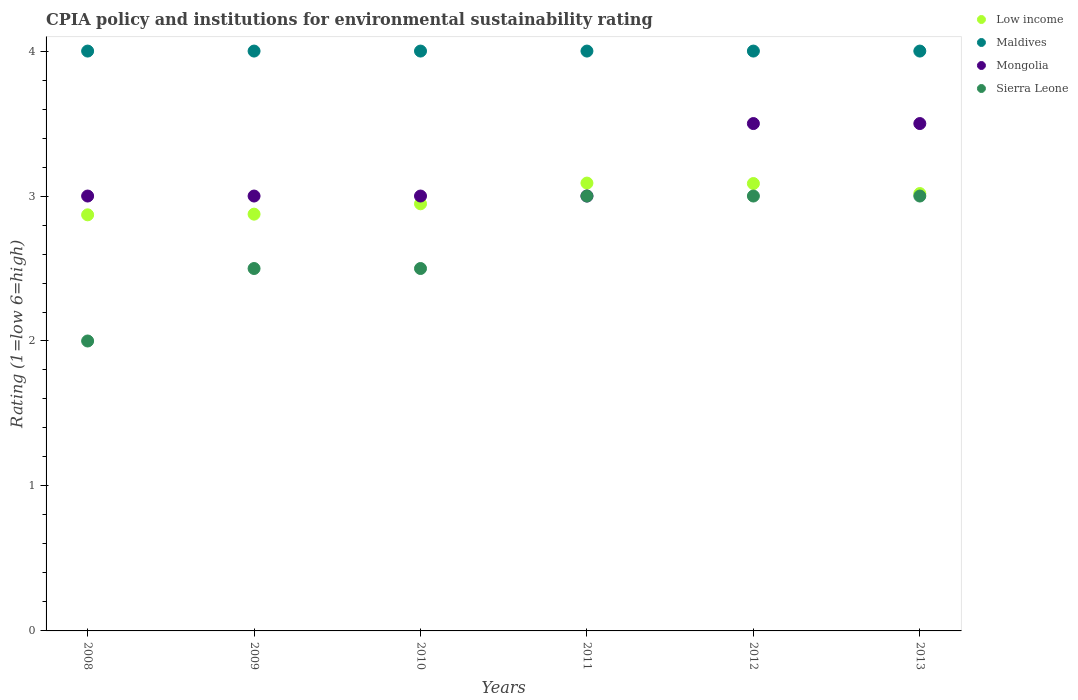How many different coloured dotlines are there?
Make the answer very short. 4. Is the number of dotlines equal to the number of legend labels?
Offer a very short reply. Yes. What is the CPIA rating in Sierra Leone in 2010?
Keep it short and to the point. 2.5. Across all years, what is the minimum CPIA rating in Low income?
Offer a terse response. 2.87. In which year was the CPIA rating in Maldives minimum?
Offer a terse response. 2008. What is the difference between the CPIA rating in Maldives in 2010 and the CPIA rating in Mongolia in 2008?
Offer a very short reply. 1. In the year 2010, what is the difference between the CPIA rating in Mongolia and CPIA rating in Low income?
Offer a very short reply. 0.05. In how many years, is the CPIA rating in Maldives greater than 2.6?
Your response must be concise. 6. What is the ratio of the CPIA rating in Maldives in 2011 to that in 2013?
Provide a succinct answer. 1. Is the CPIA rating in Sierra Leone in 2009 less than that in 2013?
Your answer should be compact. Yes. What is the difference between the highest and the lowest CPIA rating in Mongolia?
Provide a short and direct response. 0.5. In how many years, is the CPIA rating in Mongolia greater than the average CPIA rating in Mongolia taken over all years?
Keep it short and to the point. 2. Does the CPIA rating in Mongolia monotonically increase over the years?
Make the answer very short. No. Is the CPIA rating in Sierra Leone strictly greater than the CPIA rating in Mongolia over the years?
Provide a succinct answer. No. How many years are there in the graph?
Provide a succinct answer. 6. Does the graph contain grids?
Your response must be concise. No. How are the legend labels stacked?
Your answer should be compact. Vertical. What is the title of the graph?
Offer a very short reply. CPIA policy and institutions for environmental sustainability rating. Does "Faeroe Islands" appear as one of the legend labels in the graph?
Your answer should be compact. No. What is the Rating (1=low 6=high) of Low income in 2008?
Your answer should be compact. 2.87. What is the Rating (1=low 6=high) of Maldives in 2008?
Keep it short and to the point. 4. What is the Rating (1=low 6=high) in Low income in 2009?
Give a very brief answer. 2.88. What is the Rating (1=low 6=high) of Maldives in 2009?
Offer a terse response. 4. What is the Rating (1=low 6=high) in Mongolia in 2009?
Ensure brevity in your answer.  3. What is the Rating (1=low 6=high) of Sierra Leone in 2009?
Your answer should be compact. 2.5. What is the Rating (1=low 6=high) in Low income in 2010?
Offer a very short reply. 2.95. What is the Rating (1=low 6=high) in Maldives in 2010?
Your answer should be compact. 4. What is the Rating (1=low 6=high) in Mongolia in 2010?
Provide a short and direct response. 3. What is the Rating (1=low 6=high) of Low income in 2011?
Offer a very short reply. 3.09. What is the Rating (1=low 6=high) of Mongolia in 2011?
Provide a short and direct response. 3. What is the Rating (1=low 6=high) of Low income in 2012?
Provide a short and direct response. 3.09. What is the Rating (1=low 6=high) in Maldives in 2012?
Offer a terse response. 4. What is the Rating (1=low 6=high) of Mongolia in 2012?
Provide a succinct answer. 3.5. What is the Rating (1=low 6=high) of Sierra Leone in 2012?
Offer a very short reply. 3. What is the Rating (1=low 6=high) in Low income in 2013?
Give a very brief answer. 3.02. What is the Rating (1=low 6=high) in Maldives in 2013?
Offer a terse response. 4. What is the Rating (1=low 6=high) in Sierra Leone in 2013?
Keep it short and to the point. 3. Across all years, what is the maximum Rating (1=low 6=high) in Low income?
Keep it short and to the point. 3.09. Across all years, what is the maximum Rating (1=low 6=high) in Mongolia?
Offer a very short reply. 3.5. Across all years, what is the maximum Rating (1=low 6=high) of Sierra Leone?
Make the answer very short. 3. Across all years, what is the minimum Rating (1=low 6=high) of Low income?
Keep it short and to the point. 2.87. Across all years, what is the minimum Rating (1=low 6=high) of Maldives?
Your answer should be very brief. 4. Across all years, what is the minimum Rating (1=low 6=high) in Mongolia?
Ensure brevity in your answer.  3. What is the total Rating (1=low 6=high) of Low income in the graph?
Offer a very short reply. 17.88. What is the total Rating (1=low 6=high) in Sierra Leone in the graph?
Provide a short and direct response. 16. What is the difference between the Rating (1=low 6=high) in Low income in 2008 and that in 2009?
Keep it short and to the point. -0. What is the difference between the Rating (1=low 6=high) in Mongolia in 2008 and that in 2009?
Your response must be concise. 0. What is the difference between the Rating (1=low 6=high) in Sierra Leone in 2008 and that in 2009?
Provide a short and direct response. -0.5. What is the difference between the Rating (1=low 6=high) in Low income in 2008 and that in 2010?
Your answer should be very brief. -0.08. What is the difference between the Rating (1=low 6=high) in Maldives in 2008 and that in 2010?
Your answer should be compact. 0. What is the difference between the Rating (1=low 6=high) in Mongolia in 2008 and that in 2010?
Your answer should be very brief. 0. What is the difference between the Rating (1=low 6=high) of Sierra Leone in 2008 and that in 2010?
Your response must be concise. -0.5. What is the difference between the Rating (1=low 6=high) of Low income in 2008 and that in 2011?
Offer a very short reply. -0.22. What is the difference between the Rating (1=low 6=high) of Mongolia in 2008 and that in 2011?
Ensure brevity in your answer.  0. What is the difference between the Rating (1=low 6=high) of Low income in 2008 and that in 2012?
Keep it short and to the point. -0.22. What is the difference between the Rating (1=low 6=high) in Mongolia in 2008 and that in 2012?
Keep it short and to the point. -0.5. What is the difference between the Rating (1=low 6=high) of Low income in 2008 and that in 2013?
Offer a terse response. -0.15. What is the difference between the Rating (1=low 6=high) in Sierra Leone in 2008 and that in 2013?
Offer a very short reply. -1. What is the difference between the Rating (1=low 6=high) of Low income in 2009 and that in 2010?
Provide a short and direct response. -0.07. What is the difference between the Rating (1=low 6=high) in Sierra Leone in 2009 and that in 2010?
Offer a terse response. 0. What is the difference between the Rating (1=low 6=high) of Low income in 2009 and that in 2011?
Your answer should be compact. -0.21. What is the difference between the Rating (1=low 6=high) of Low income in 2009 and that in 2012?
Provide a succinct answer. -0.21. What is the difference between the Rating (1=low 6=high) of Maldives in 2009 and that in 2012?
Keep it short and to the point. 0. What is the difference between the Rating (1=low 6=high) of Mongolia in 2009 and that in 2012?
Your answer should be compact. -0.5. What is the difference between the Rating (1=low 6=high) in Low income in 2009 and that in 2013?
Your response must be concise. -0.14. What is the difference between the Rating (1=low 6=high) of Mongolia in 2009 and that in 2013?
Give a very brief answer. -0.5. What is the difference between the Rating (1=low 6=high) of Sierra Leone in 2009 and that in 2013?
Keep it short and to the point. -0.5. What is the difference between the Rating (1=low 6=high) of Low income in 2010 and that in 2011?
Your answer should be very brief. -0.14. What is the difference between the Rating (1=low 6=high) in Sierra Leone in 2010 and that in 2011?
Provide a short and direct response. -0.5. What is the difference between the Rating (1=low 6=high) in Low income in 2010 and that in 2012?
Provide a short and direct response. -0.14. What is the difference between the Rating (1=low 6=high) in Maldives in 2010 and that in 2012?
Your answer should be compact. 0. What is the difference between the Rating (1=low 6=high) of Mongolia in 2010 and that in 2012?
Keep it short and to the point. -0.5. What is the difference between the Rating (1=low 6=high) in Sierra Leone in 2010 and that in 2012?
Provide a succinct answer. -0.5. What is the difference between the Rating (1=low 6=high) of Low income in 2010 and that in 2013?
Keep it short and to the point. -0.07. What is the difference between the Rating (1=low 6=high) in Mongolia in 2010 and that in 2013?
Make the answer very short. -0.5. What is the difference between the Rating (1=low 6=high) of Sierra Leone in 2010 and that in 2013?
Ensure brevity in your answer.  -0.5. What is the difference between the Rating (1=low 6=high) in Low income in 2011 and that in 2012?
Your answer should be very brief. 0. What is the difference between the Rating (1=low 6=high) of Maldives in 2011 and that in 2012?
Offer a very short reply. 0. What is the difference between the Rating (1=low 6=high) in Sierra Leone in 2011 and that in 2012?
Make the answer very short. 0. What is the difference between the Rating (1=low 6=high) in Low income in 2011 and that in 2013?
Offer a terse response. 0.07. What is the difference between the Rating (1=low 6=high) of Maldives in 2011 and that in 2013?
Give a very brief answer. 0. What is the difference between the Rating (1=low 6=high) of Sierra Leone in 2011 and that in 2013?
Your answer should be very brief. 0. What is the difference between the Rating (1=low 6=high) in Low income in 2012 and that in 2013?
Your response must be concise. 0.07. What is the difference between the Rating (1=low 6=high) in Mongolia in 2012 and that in 2013?
Offer a very short reply. 0. What is the difference between the Rating (1=low 6=high) in Low income in 2008 and the Rating (1=low 6=high) in Maldives in 2009?
Your answer should be compact. -1.13. What is the difference between the Rating (1=low 6=high) of Low income in 2008 and the Rating (1=low 6=high) of Mongolia in 2009?
Your response must be concise. -0.13. What is the difference between the Rating (1=low 6=high) in Low income in 2008 and the Rating (1=low 6=high) in Sierra Leone in 2009?
Give a very brief answer. 0.37. What is the difference between the Rating (1=low 6=high) in Maldives in 2008 and the Rating (1=low 6=high) in Sierra Leone in 2009?
Your answer should be very brief. 1.5. What is the difference between the Rating (1=low 6=high) of Mongolia in 2008 and the Rating (1=low 6=high) of Sierra Leone in 2009?
Your response must be concise. 0.5. What is the difference between the Rating (1=low 6=high) of Low income in 2008 and the Rating (1=low 6=high) of Maldives in 2010?
Offer a terse response. -1.13. What is the difference between the Rating (1=low 6=high) of Low income in 2008 and the Rating (1=low 6=high) of Mongolia in 2010?
Your answer should be compact. -0.13. What is the difference between the Rating (1=low 6=high) of Low income in 2008 and the Rating (1=low 6=high) of Sierra Leone in 2010?
Your answer should be very brief. 0.37. What is the difference between the Rating (1=low 6=high) of Mongolia in 2008 and the Rating (1=low 6=high) of Sierra Leone in 2010?
Give a very brief answer. 0.5. What is the difference between the Rating (1=low 6=high) in Low income in 2008 and the Rating (1=low 6=high) in Maldives in 2011?
Provide a succinct answer. -1.13. What is the difference between the Rating (1=low 6=high) of Low income in 2008 and the Rating (1=low 6=high) of Mongolia in 2011?
Offer a terse response. -0.13. What is the difference between the Rating (1=low 6=high) in Low income in 2008 and the Rating (1=low 6=high) in Sierra Leone in 2011?
Ensure brevity in your answer.  -0.13. What is the difference between the Rating (1=low 6=high) in Maldives in 2008 and the Rating (1=low 6=high) in Mongolia in 2011?
Your answer should be compact. 1. What is the difference between the Rating (1=low 6=high) in Low income in 2008 and the Rating (1=low 6=high) in Maldives in 2012?
Keep it short and to the point. -1.13. What is the difference between the Rating (1=low 6=high) of Low income in 2008 and the Rating (1=low 6=high) of Mongolia in 2012?
Give a very brief answer. -0.63. What is the difference between the Rating (1=low 6=high) in Low income in 2008 and the Rating (1=low 6=high) in Sierra Leone in 2012?
Ensure brevity in your answer.  -0.13. What is the difference between the Rating (1=low 6=high) of Mongolia in 2008 and the Rating (1=low 6=high) of Sierra Leone in 2012?
Provide a succinct answer. 0. What is the difference between the Rating (1=low 6=high) in Low income in 2008 and the Rating (1=low 6=high) in Maldives in 2013?
Offer a very short reply. -1.13. What is the difference between the Rating (1=low 6=high) of Low income in 2008 and the Rating (1=low 6=high) of Mongolia in 2013?
Your response must be concise. -0.63. What is the difference between the Rating (1=low 6=high) of Low income in 2008 and the Rating (1=low 6=high) of Sierra Leone in 2013?
Give a very brief answer. -0.13. What is the difference between the Rating (1=low 6=high) in Low income in 2009 and the Rating (1=low 6=high) in Maldives in 2010?
Your response must be concise. -1.12. What is the difference between the Rating (1=low 6=high) in Low income in 2009 and the Rating (1=low 6=high) in Mongolia in 2010?
Offer a terse response. -0.12. What is the difference between the Rating (1=low 6=high) in Maldives in 2009 and the Rating (1=low 6=high) in Mongolia in 2010?
Your response must be concise. 1. What is the difference between the Rating (1=low 6=high) of Maldives in 2009 and the Rating (1=low 6=high) of Sierra Leone in 2010?
Provide a short and direct response. 1.5. What is the difference between the Rating (1=low 6=high) of Low income in 2009 and the Rating (1=low 6=high) of Maldives in 2011?
Offer a very short reply. -1.12. What is the difference between the Rating (1=low 6=high) of Low income in 2009 and the Rating (1=low 6=high) of Mongolia in 2011?
Provide a succinct answer. -0.12. What is the difference between the Rating (1=low 6=high) of Low income in 2009 and the Rating (1=low 6=high) of Sierra Leone in 2011?
Your response must be concise. -0.12. What is the difference between the Rating (1=low 6=high) of Mongolia in 2009 and the Rating (1=low 6=high) of Sierra Leone in 2011?
Keep it short and to the point. 0. What is the difference between the Rating (1=low 6=high) in Low income in 2009 and the Rating (1=low 6=high) in Maldives in 2012?
Ensure brevity in your answer.  -1.12. What is the difference between the Rating (1=low 6=high) of Low income in 2009 and the Rating (1=low 6=high) of Mongolia in 2012?
Your answer should be very brief. -0.62. What is the difference between the Rating (1=low 6=high) of Low income in 2009 and the Rating (1=low 6=high) of Sierra Leone in 2012?
Offer a very short reply. -0.12. What is the difference between the Rating (1=low 6=high) of Maldives in 2009 and the Rating (1=low 6=high) of Mongolia in 2012?
Your answer should be compact. 0.5. What is the difference between the Rating (1=low 6=high) in Maldives in 2009 and the Rating (1=low 6=high) in Sierra Leone in 2012?
Provide a short and direct response. 1. What is the difference between the Rating (1=low 6=high) in Low income in 2009 and the Rating (1=low 6=high) in Maldives in 2013?
Make the answer very short. -1.12. What is the difference between the Rating (1=low 6=high) of Low income in 2009 and the Rating (1=low 6=high) of Mongolia in 2013?
Offer a very short reply. -0.62. What is the difference between the Rating (1=low 6=high) of Low income in 2009 and the Rating (1=low 6=high) of Sierra Leone in 2013?
Give a very brief answer. -0.12. What is the difference between the Rating (1=low 6=high) in Maldives in 2009 and the Rating (1=low 6=high) in Mongolia in 2013?
Make the answer very short. 0.5. What is the difference between the Rating (1=low 6=high) of Mongolia in 2009 and the Rating (1=low 6=high) of Sierra Leone in 2013?
Offer a terse response. 0. What is the difference between the Rating (1=low 6=high) in Low income in 2010 and the Rating (1=low 6=high) in Maldives in 2011?
Offer a very short reply. -1.05. What is the difference between the Rating (1=low 6=high) in Low income in 2010 and the Rating (1=low 6=high) in Mongolia in 2011?
Provide a succinct answer. -0.05. What is the difference between the Rating (1=low 6=high) of Low income in 2010 and the Rating (1=low 6=high) of Sierra Leone in 2011?
Your answer should be compact. -0.05. What is the difference between the Rating (1=low 6=high) of Low income in 2010 and the Rating (1=low 6=high) of Maldives in 2012?
Provide a short and direct response. -1.05. What is the difference between the Rating (1=low 6=high) of Low income in 2010 and the Rating (1=low 6=high) of Mongolia in 2012?
Your answer should be very brief. -0.55. What is the difference between the Rating (1=low 6=high) in Low income in 2010 and the Rating (1=low 6=high) in Sierra Leone in 2012?
Offer a terse response. -0.05. What is the difference between the Rating (1=low 6=high) in Mongolia in 2010 and the Rating (1=low 6=high) in Sierra Leone in 2012?
Ensure brevity in your answer.  0. What is the difference between the Rating (1=low 6=high) of Low income in 2010 and the Rating (1=low 6=high) of Maldives in 2013?
Make the answer very short. -1.05. What is the difference between the Rating (1=low 6=high) of Low income in 2010 and the Rating (1=low 6=high) of Mongolia in 2013?
Make the answer very short. -0.55. What is the difference between the Rating (1=low 6=high) of Low income in 2010 and the Rating (1=low 6=high) of Sierra Leone in 2013?
Give a very brief answer. -0.05. What is the difference between the Rating (1=low 6=high) in Mongolia in 2010 and the Rating (1=low 6=high) in Sierra Leone in 2013?
Your answer should be very brief. 0. What is the difference between the Rating (1=low 6=high) of Low income in 2011 and the Rating (1=low 6=high) of Maldives in 2012?
Provide a succinct answer. -0.91. What is the difference between the Rating (1=low 6=high) of Low income in 2011 and the Rating (1=low 6=high) of Mongolia in 2012?
Provide a short and direct response. -0.41. What is the difference between the Rating (1=low 6=high) of Low income in 2011 and the Rating (1=low 6=high) of Sierra Leone in 2012?
Give a very brief answer. 0.09. What is the difference between the Rating (1=low 6=high) in Maldives in 2011 and the Rating (1=low 6=high) in Mongolia in 2012?
Keep it short and to the point. 0.5. What is the difference between the Rating (1=low 6=high) of Mongolia in 2011 and the Rating (1=low 6=high) of Sierra Leone in 2012?
Provide a short and direct response. 0. What is the difference between the Rating (1=low 6=high) of Low income in 2011 and the Rating (1=low 6=high) of Maldives in 2013?
Offer a very short reply. -0.91. What is the difference between the Rating (1=low 6=high) of Low income in 2011 and the Rating (1=low 6=high) of Mongolia in 2013?
Your answer should be compact. -0.41. What is the difference between the Rating (1=low 6=high) of Low income in 2011 and the Rating (1=low 6=high) of Sierra Leone in 2013?
Your answer should be compact. 0.09. What is the difference between the Rating (1=low 6=high) of Low income in 2012 and the Rating (1=low 6=high) of Maldives in 2013?
Ensure brevity in your answer.  -0.91. What is the difference between the Rating (1=low 6=high) of Low income in 2012 and the Rating (1=low 6=high) of Mongolia in 2013?
Provide a short and direct response. -0.41. What is the difference between the Rating (1=low 6=high) in Low income in 2012 and the Rating (1=low 6=high) in Sierra Leone in 2013?
Provide a short and direct response. 0.09. What is the difference between the Rating (1=low 6=high) in Maldives in 2012 and the Rating (1=low 6=high) in Mongolia in 2013?
Your response must be concise. 0.5. What is the difference between the Rating (1=low 6=high) of Mongolia in 2012 and the Rating (1=low 6=high) of Sierra Leone in 2013?
Give a very brief answer. 0.5. What is the average Rating (1=low 6=high) in Low income per year?
Keep it short and to the point. 2.98. What is the average Rating (1=low 6=high) in Mongolia per year?
Make the answer very short. 3.17. What is the average Rating (1=low 6=high) of Sierra Leone per year?
Offer a very short reply. 2.67. In the year 2008, what is the difference between the Rating (1=low 6=high) of Low income and Rating (1=low 6=high) of Maldives?
Your answer should be very brief. -1.13. In the year 2008, what is the difference between the Rating (1=low 6=high) of Low income and Rating (1=low 6=high) of Mongolia?
Ensure brevity in your answer.  -0.13. In the year 2008, what is the difference between the Rating (1=low 6=high) in Low income and Rating (1=low 6=high) in Sierra Leone?
Your answer should be compact. 0.87. In the year 2009, what is the difference between the Rating (1=low 6=high) of Low income and Rating (1=low 6=high) of Maldives?
Offer a very short reply. -1.12. In the year 2009, what is the difference between the Rating (1=low 6=high) of Low income and Rating (1=low 6=high) of Mongolia?
Your answer should be compact. -0.12. In the year 2009, what is the difference between the Rating (1=low 6=high) in Low income and Rating (1=low 6=high) in Sierra Leone?
Provide a short and direct response. 0.38. In the year 2009, what is the difference between the Rating (1=low 6=high) in Maldives and Rating (1=low 6=high) in Sierra Leone?
Provide a short and direct response. 1.5. In the year 2009, what is the difference between the Rating (1=low 6=high) of Mongolia and Rating (1=low 6=high) of Sierra Leone?
Your response must be concise. 0.5. In the year 2010, what is the difference between the Rating (1=low 6=high) of Low income and Rating (1=low 6=high) of Maldives?
Keep it short and to the point. -1.05. In the year 2010, what is the difference between the Rating (1=low 6=high) in Low income and Rating (1=low 6=high) in Mongolia?
Your answer should be compact. -0.05. In the year 2010, what is the difference between the Rating (1=low 6=high) in Low income and Rating (1=low 6=high) in Sierra Leone?
Provide a short and direct response. 0.45. In the year 2010, what is the difference between the Rating (1=low 6=high) in Mongolia and Rating (1=low 6=high) in Sierra Leone?
Offer a terse response. 0.5. In the year 2011, what is the difference between the Rating (1=low 6=high) in Low income and Rating (1=low 6=high) in Maldives?
Your answer should be compact. -0.91. In the year 2011, what is the difference between the Rating (1=low 6=high) in Low income and Rating (1=low 6=high) in Mongolia?
Provide a short and direct response. 0.09. In the year 2011, what is the difference between the Rating (1=low 6=high) of Low income and Rating (1=low 6=high) of Sierra Leone?
Your response must be concise. 0.09. In the year 2011, what is the difference between the Rating (1=low 6=high) in Maldives and Rating (1=low 6=high) in Mongolia?
Offer a very short reply. 1. In the year 2011, what is the difference between the Rating (1=low 6=high) of Maldives and Rating (1=low 6=high) of Sierra Leone?
Give a very brief answer. 1. In the year 2012, what is the difference between the Rating (1=low 6=high) of Low income and Rating (1=low 6=high) of Maldives?
Your answer should be compact. -0.91. In the year 2012, what is the difference between the Rating (1=low 6=high) in Low income and Rating (1=low 6=high) in Mongolia?
Offer a terse response. -0.41. In the year 2012, what is the difference between the Rating (1=low 6=high) in Low income and Rating (1=low 6=high) in Sierra Leone?
Offer a terse response. 0.09. In the year 2012, what is the difference between the Rating (1=low 6=high) of Maldives and Rating (1=low 6=high) of Mongolia?
Keep it short and to the point. 0.5. In the year 2012, what is the difference between the Rating (1=low 6=high) of Maldives and Rating (1=low 6=high) of Sierra Leone?
Make the answer very short. 1. In the year 2013, what is the difference between the Rating (1=low 6=high) of Low income and Rating (1=low 6=high) of Maldives?
Your answer should be very brief. -0.98. In the year 2013, what is the difference between the Rating (1=low 6=high) of Low income and Rating (1=low 6=high) of Mongolia?
Give a very brief answer. -0.48. In the year 2013, what is the difference between the Rating (1=low 6=high) of Low income and Rating (1=low 6=high) of Sierra Leone?
Your response must be concise. 0.02. In the year 2013, what is the difference between the Rating (1=low 6=high) in Maldives and Rating (1=low 6=high) in Mongolia?
Keep it short and to the point. 0.5. In the year 2013, what is the difference between the Rating (1=low 6=high) of Maldives and Rating (1=low 6=high) of Sierra Leone?
Make the answer very short. 1. What is the ratio of the Rating (1=low 6=high) of Low income in 2008 to that in 2010?
Your answer should be very brief. 0.97. What is the ratio of the Rating (1=low 6=high) in Maldives in 2008 to that in 2010?
Offer a very short reply. 1. What is the ratio of the Rating (1=low 6=high) in Mongolia in 2008 to that in 2010?
Keep it short and to the point. 1. What is the ratio of the Rating (1=low 6=high) of Low income in 2008 to that in 2011?
Ensure brevity in your answer.  0.93. What is the ratio of the Rating (1=low 6=high) in Mongolia in 2008 to that in 2011?
Your answer should be very brief. 1. What is the ratio of the Rating (1=low 6=high) in Sierra Leone in 2008 to that in 2011?
Give a very brief answer. 0.67. What is the ratio of the Rating (1=low 6=high) of Low income in 2008 to that in 2012?
Provide a short and direct response. 0.93. What is the ratio of the Rating (1=low 6=high) of Maldives in 2008 to that in 2012?
Provide a short and direct response. 1. What is the ratio of the Rating (1=low 6=high) in Mongolia in 2008 to that in 2012?
Your response must be concise. 0.86. What is the ratio of the Rating (1=low 6=high) of Sierra Leone in 2008 to that in 2012?
Offer a terse response. 0.67. What is the ratio of the Rating (1=low 6=high) of Low income in 2008 to that in 2013?
Your answer should be very brief. 0.95. What is the ratio of the Rating (1=low 6=high) of Maldives in 2008 to that in 2013?
Your answer should be compact. 1. What is the ratio of the Rating (1=low 6=high) in Mongolia in 2008 to that in 2013?
Offer a terse response. 0.86. What is the ratio of the Rating (1=low 6=high) in Low income in 2009 to that in 2010?
Offer a terse response. 0.98. What is the ratio of the Rating (1=low 6=high) in Mongolia in 2009 to that in 2010?
Your response must be concise. 1. What is the ratio of the Rating (1=low 6=high) of Low income in 2009 to that in 2011?
Keep it short and to the point. 0.93. What is the ratio of the Rating (1=low 6=high) of Maldives in 2009 to that in 2011?
Your answer should be very brief. 1. What is the ratio of the Rating (1=low 6=high) of Sierra Leone in 2009 to that in 2011?
Ensure brevity in your answer.  0.83. What is the ratio of the Rating (1=low 6=high) of Low income in 2009 to that in 2012?
Your answer should be compact. 0.93. What is the ratio of the Rating (1=low 6=high) of Maldives in 2009 to that in 2012?
Ensure brevity in your answer.  1. What is the ratio of the Rating (1=low 6=high) of Mongolia in 2009 to that in 2012?
Your answer should be compact. 0.86. What is the ratio of the Rating (1=low 6=high) of Low income in 2009 to that in 2013?
Keep it short and to the point. 0.95. What is the ratio of the Rating (1=low 6=high) of Mongolia in 2009 to that in 2013?
Give a very brief answer. 0.86. What is the ratio of the Rating (1=low 6=high) of Sierra Leone in 2009 to that in 2013?
Keep it short and to the point. 0.83. What is the ratio of the Rating (1=low 6=high) of Low income in 2010 to that in 2011?
Your response must be concise. 0.95. What is the ratio of the Rating (1=low 6=high) of Sierra Leone in 2010 to that in 2011?
Your response must be concise. 0.83. What is the ratio of the Rating (1=low 6=high) in Low income in 2010 to that in 2012?
Offer a terse response. 0.95. What is the ratio of the Rating (1=low 6=high) of Low income in 2010 to that in 2013?
Offer a very short reply. 0.98. What is the ratio of the Rating (1=low 6=high) of Sierra Leone in 2010 to that in 2013?
Ensure brevity in your answer.  0.83. What is the ratio of the Rating (1=low 6=high) of Low income in 2011 to that in 2012?
Offer a very short reply. 1. What is the ratio of the Rating (1=low 6=high) of Low income in 2011 to that in 2013?
Keep it short and to the point. 1.02. What is the ratio of the Rating (1=low 6=high) in Maldives in 2011 to that in 2013?
Your answer should be compact. 1. What is the ratio of the Rating (1=low 6=high) in Mongolia in 2011 to that in 2013?
Offer a terse response. 0.86. What is the ratio of the Rating (1=low 6=high) of Sierra Leone in 2011 to that in 2013?
Give a very brief answer. 1. What is the ratio of the Rating (1=low 6=high) of Low income in 2012 to that in 2013?
Keep it short and to the point. 1.02. What is the ratio of the Rating (1=low 6=high) of Maldives in 2012 to that in 2013?
Provide a succinct answer. 1. What is the ratio of the Rating (1=low 6=high) in Sierra Leone in 2012 to that in 2013?
Your answer should be compact. 1. What is the difference between the highest and the second highest Rating (1=low 6=high) in Low income?
Offer a very short reply. 0. What is the difference between the highest and the second highest Rating (1=low 6=high) of Maldives?
Give a very brief answer. 0. What is the difference between the highest and the second highest Rating (1=low 6=high) of Sierra Leone?
Make the answer very short. 0. What is the difference between the highest and the lowest Rating (1=low 6=high) in Low income?
Your answer should be very brief. 0.22. What is the difference between the highest and the lowest Rating (1=low 6=high) of Maldives?
Provide a short and direct response. 0. What is the difference between the highest and the lowest Rating (1=low 6=high) in Mongolia?
Ensure brevity in your answer.  0.5. What is the difference between the highest and the lowest Rating (1=low 6=high) in Sierra Leone?
Ensure brevity in your answer.  1. 